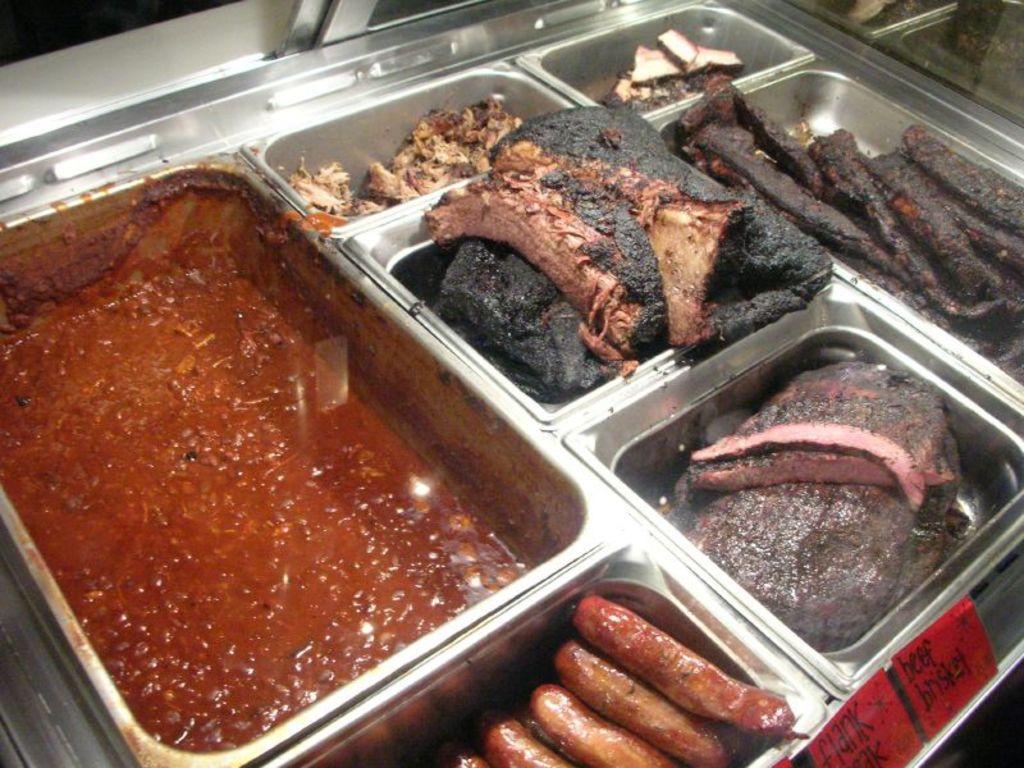In one or two sentences, can you explain what this image depicts? In this image we can see group of food and sausages are kept in different containers are placed on the table. 